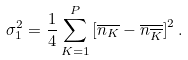Convert formula to latex. <formula><loc_0><loc_0><loc_500><loc_500>\sigma _ { 1 } ^ { 2 } = \frac { 1 } { 4 } \sum _ { K = 1 } ^ { P } \left [ \overline { n _ { K } } - \overline { n _ { \overline { K } } } \right ] ^ { 2 } .</formula> 